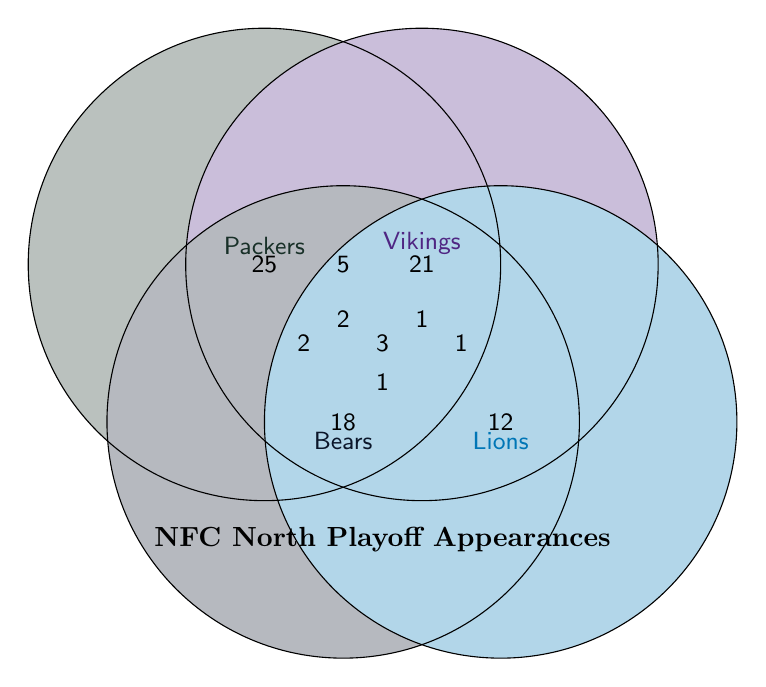What is the total number of playoff appearances for the Packers? The Packers' total playoff appearances are shown in their own circle.
Answer: 25 Which team has the fewest playoff appearances? By observing the individual circles, the Lions have the fewest at 12.
Answer: Lions How many times have the Packers and Vikings both appeared in the playoffs? The intersection of the Packers and Vikings circles shows the number of shared playoff appearances.
Answer: 5 What is the sum of playoff appearances when all teams are considered separately? Add up Packers (25), Vikings (21), Bears (18), and Lions (12).
Answer: 76 Which common playoff appearances have occurred for all four NFC North teams? The intersection of all four circles (Packers, Vikings, Bears, Lions) is labeled.
Answer: 1 How many times have the Packers and Bears both been in the playoffs but not with the Vikings? The intersection of Packers and Bears excluding the Vikings area indicates these instances.
Answer: 4 What is the combined number of appearances where the Packers, Vikings, and Bears have all been in the playoffs? Look at the intersection labeled Packers+Vikings+Bears.
Answer: 2 Which two teams have the most combined playoff appearances? Compare intersections: Packers+Vikings (5), Packers+Bears (4), Packers+Lions (2), Vikings+Bears (3), Vikings+Lions (1), and Bears+Lions (1). Packers+Vikings has the most.
Answer: Packers and Vikings What is the total of joint playoff appearances among any two-team combinations? Add all two-team intersections: 5 (Packers+Vikings) + 4 (Packers+Bears) + 2 (Packers+Lions) + 3 (Vikings+Bears) + 1 (Vikings+Lions) + 1 (Bears+Lions).
Answer: 16 How many total years have the Packers been in the playoffs where at least one other NFC North team was also in the playoffs? Sum all intersection values involving Packers: 5 (Packers+Vikings) + 4 (Packers+Bears) + 2 (Packers+Lions) + 2 (Packers+Vikings+Bears) + 1 (Packers+Vikings+Lions) + 1 (all teams).
Answer: 15 